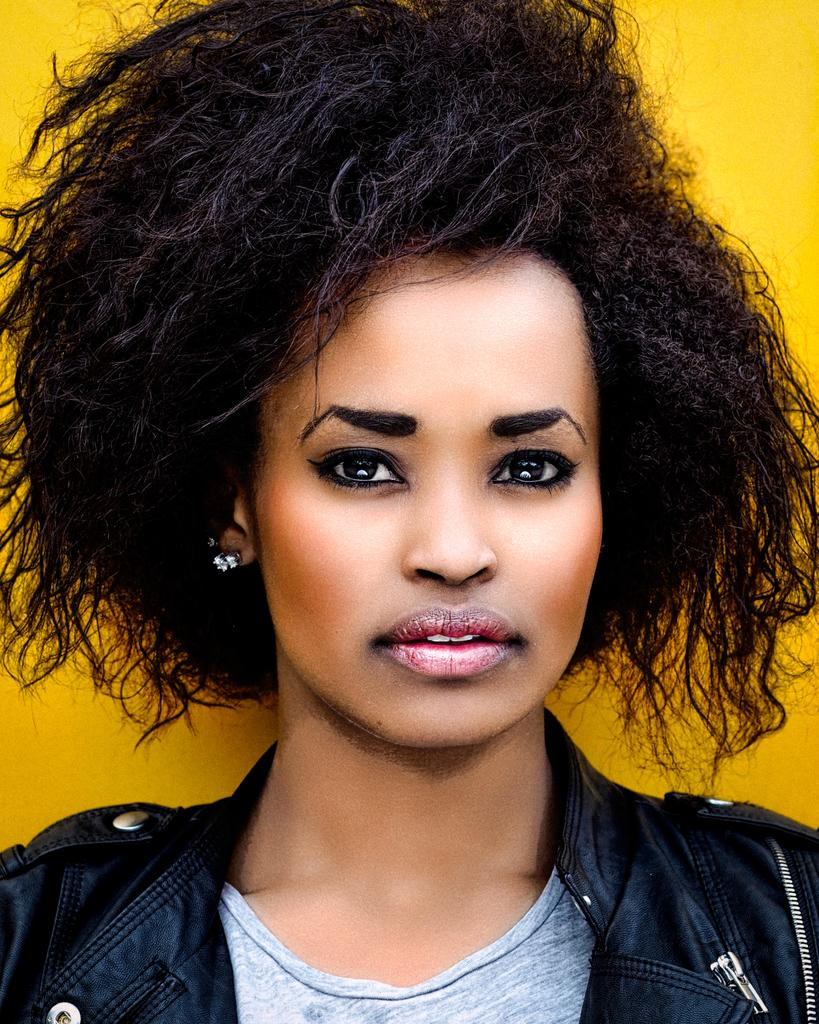Who is present in the image? There is a woman in the image. What is the woman wearing? The woman is wearing clothes and ear studs. What is the color of the background in the image? The background color is yellow. How many ants can be seen crawling on the woman's clothes in the image? There are no ants present in the image. What causes the burst of color in the image? There is no burst of color in the image; the background color is consistent and yellow. 